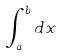<formula> <loc_0><loc_0><loc_500><loc_500>\int _ { a } ^ { b } d x</formula> 